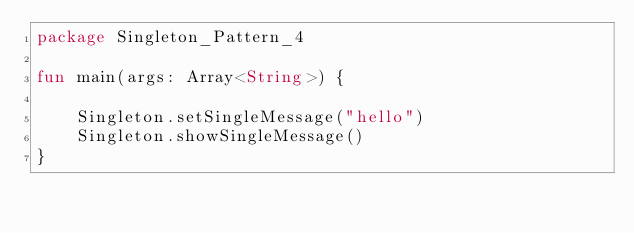Convert code to text. <code><loc_0><loc_0><loc_500><loc_500><_Kotlin_>package Singleton_Pattern_4

fun main(args: Array<String>) {

    Singleton.setSingleMessage("hello")
    Singleton.showSingleMessage()
}</code> 